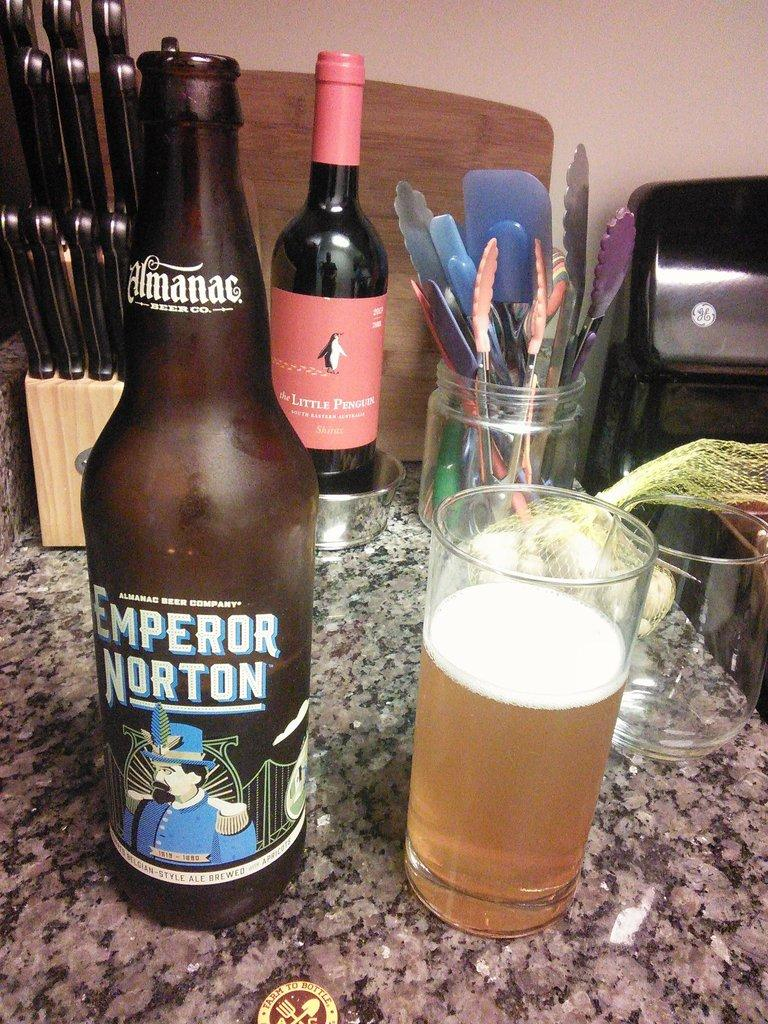Provide a one-sentence caption for the provided image. a bottle of emporer Norton on a table full of stuff. 